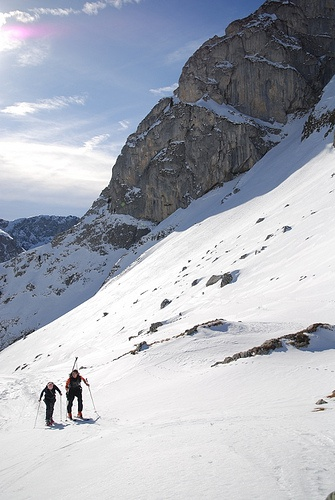Describe the objects in this image and their specific colors. I can see people in darkgray, black, white, and gray tones, people in darkgray, black, white, and gray tones, skis in darkgray, gray, and black tones, skis in darkgray, gray, black, and maroon tones, and skis in darkgray, lightgray, black, and gray tones in this image. 